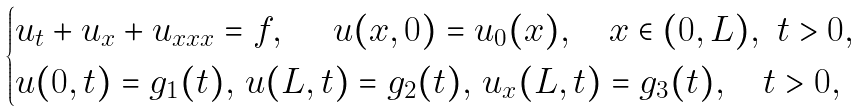<formula> <loc_0><loc_0><loc_500><loc_500>\begin{cases} u _ { t } + u _ { x } + u _ { x x x } = f , \quad \ u ( x , 0 ) = u _ { 0 } ( x ) , \quad x \in ( 0 , L ) , \ t > 0 , \\ u ( 0 , t ) = g _ { 1 } ( t ) , \, u ( L , t ) = g _ { 2 } ( t ) , \, u _ { x } ( L , t ) = g _ { 3 } ( t ) , \quad t > 0 , \end{cases}</formula> 